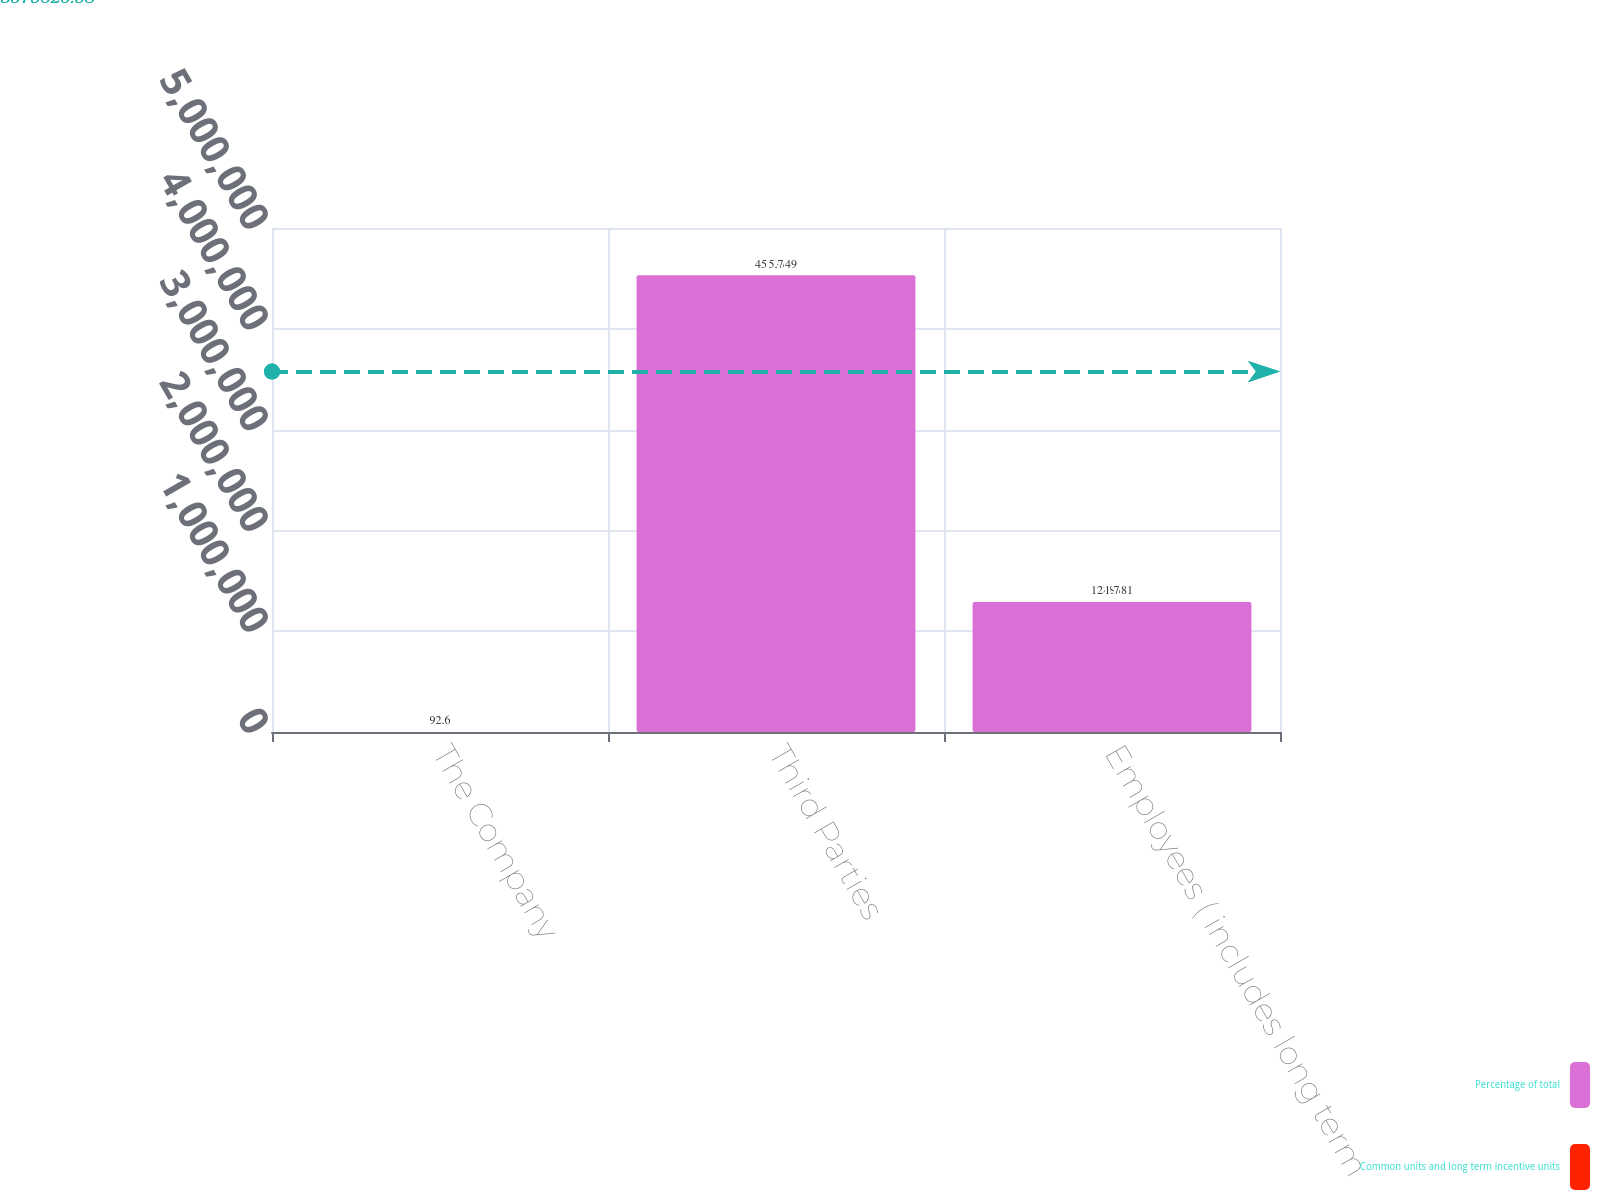Convert chart to OTSL. <chart><loc_0><loc_0><loc_500><loc_500><stacked_bar_chart><ecel><fcel>The Company<fcel>Third Parties<fcel>Employees ( includes long term<nl><fcel>Percentage of total<fcel>92.6<fcel>4.53055e+06<fcel>1.28858e+06<nl><fcel>Common units and long term incentive units<fcel>92.6<fcel>5.7<fcel>1.7<nl></chart> 